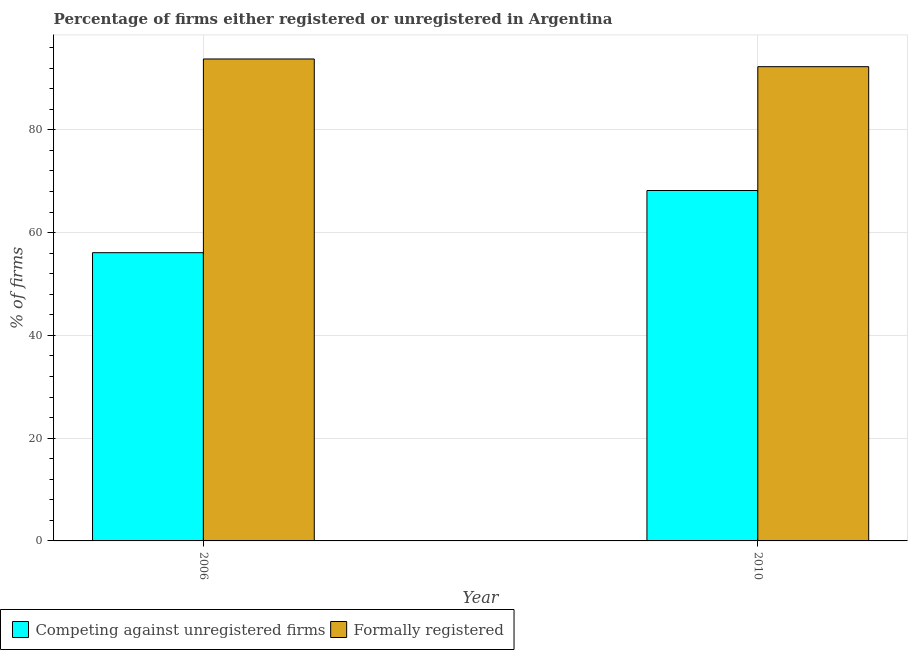How many different coloured bars are there?
Your answer should be very brief. 2. How many bars are there on the 1st tick from the left?
Make the answer very short. 2. How many bars are there on the 2nd tick from the right?
Provide a short and direct response. 2. In how many cases, is the number of bars for a given year not equal to the number of legend labels?
Your response must be concise. 0. What is the percentage of formally registered firms in 2010?
Your answer should be very brief. 92.3. Across all years, what is the maximum percentage of registered firms?
Your response must be concise. 68.2. Across all years, what is the minimum percentage of registered firms?
Provide a succinct answer. 56.1. In which year was the percentage of formally registered firms maximum?
Your answer should be compact. 2006. What is the total percentage of registered firms in the graph?
Keep it short and to the point. 124.3. What is the average percentage of registered firms per year?
Your response must be concise. 62.15. In how many years, is the percentage of registered firms greater than 72 %?
Offer a very short reply. 0. What is the ratio of the percentage of registered firms in 2006 to that in 2010?
Offer a terse response. 0.82. In how many years, is the percentage of registered firms greater than the average percentage of registered firms taken over all years?
Give a very brief answer. 1. What does the 2nd bar from the left in 2010 represents?
Give a very brief answer. Formally registered. What does the 1st bar from the right in 2006 represents?
Make the answer very short. Formally registered. How many bars are there?
Provide a succinct answer. 4. Are all the bars in the graph horizontal?
Your answer should be very brief. No. What is the difference between two consecutive major ticks on the Y-axis?
Your answer should be compact. 20. Are the values on the major ticks of Y-axis written in scientific E-notation?
Offer a very short reply. No. Where does the legend appear in the graph?
Your answer should be very brief. Bottom left. What is the title of the graph?
Your response must be concise. Percentage of firms either registered or unregistered in Argentina. What is the label or title of the X-axis?
Your answer should be very brief. Year. What is the label or title of the Y-axis?
Provide a short and direct response. % of firms. What is the % of firms of Competing against unregistered firms in 2006?
Your answer should be very brief. 56.1. What is the % of firms in Formally registered in 2006?
Provide a short and direct response. 93.8. What is the % of firms of Competing against unregistered firms in 2010?
Offer a terse response. 68.2. What is the % of firms in Formally registered in 2010?
Your response must be concise. 92.3. Across all years, what is the maximum % of firms of Competing against unregistered firms?
Ensure brevity in your answer.  68.2. Across all years, what is the maximum % of firms in Formally registered?
Keep it short and to the point. 93.8. Across all years, what is the minimum % of firms in Competing against unregistered firms?
Ensure brevity in your answer.  56.1. Across all years, what is the minimum % of firms of Formally registered?
Provide a short and direct response. 92.3. What is the total % of firms of Competing against unregistered firms in the graph?
Your answer should be compact. 124.3. What is the total % of firms of Formally registered in the graph?
Ensure brevity in your answer.  186.1. What is the difference between the % of firms of Competing against unregistered firms in 2006 and that in 2010?
Give a very brief answer. -12.1. What is the difference between the % of firms of Formally registered in 2006 and that in 2010?
Your answer should be very brief. 1.5. What is the difference between the % of firms in Competing against unregistered firms in 2006 and the % of firms in Formally registered in 2010?
Give a very brief answer. -36.2. What is the average % of firms of Competing against unregistered firms per year?
Give a very brief answer. 62.15. What is the average % of firms in Formally registered per year?
Your response must be concise. 93.05. In the year 2006, what is the difference between the % of firms of Competing against unregistered firms and % of firms of Formally registered?
Offer a terse response. -37.7. In the year 2010, what is the difference between the % of firms of Competing against unregistered firms and % of firms of Formally registered?
Your answer should be compact. -24.1. What is the ratio of the % of firms of Competing against unregistered firms in 2006 to that in 2010?
Your answer should be compact. 0.82. What is the ratio of the % of firms in Formally registered in 2006 to that in 2010?
Give a very brief answer. 1.02. What is the difference between the highest and the second highest % of firms of Competing against unregistered firms?
Ensure brevity in your answer.  12.1. What is the difference between the highest and the lowest % of firms in Competing against unregistered firms?
Your answer should be very brief. 12.1. 